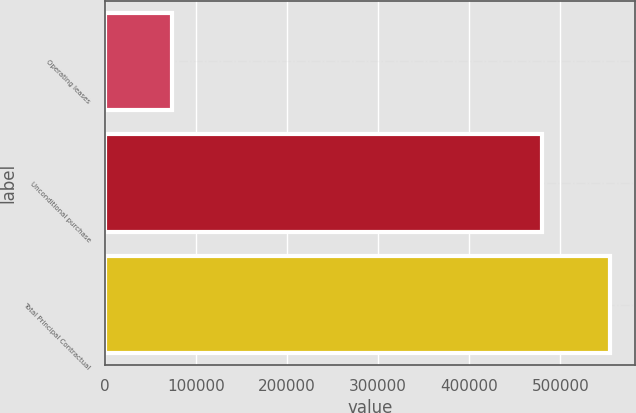<chart> <loc_0><loc_0><loc_500><loc_500><bar_chart><fcel>Operating leases<fcel>Unconditional purchase<fcel>Total Principal Contractual<nl><fcel>74288<fcel>480109<fcel>554397<nl></chart> 